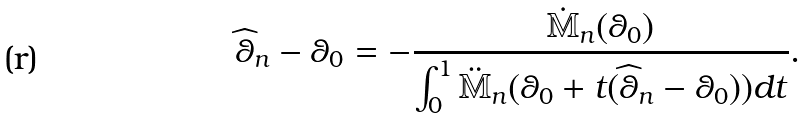<formula> <loc_0><loc_0><loc_500><loc_500>\widehat { \theta } _ { n } - \theta _ { 0 } = - \frac { \dot { \mathbb { M } } _ { n } ( \theta _ { 0 } ) } { \int _ { 0 } ^ { 1 } \ddot { \mathbb { M } } _ { n } ( \theta _ { 0 } + t ( \widehat { \theta } _ { n } - \theta _ { 0 } ) ) d t } .</formula> 